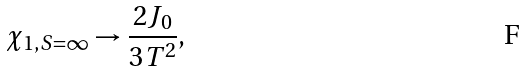<formula> <loc_0><loc_0><loc_500><loc_500>\chi _ { 1 , S = \infty } \rightarrow \frac { 2 J _ { 0 } } { 3 T ^ { 2 } } ,</formula> 